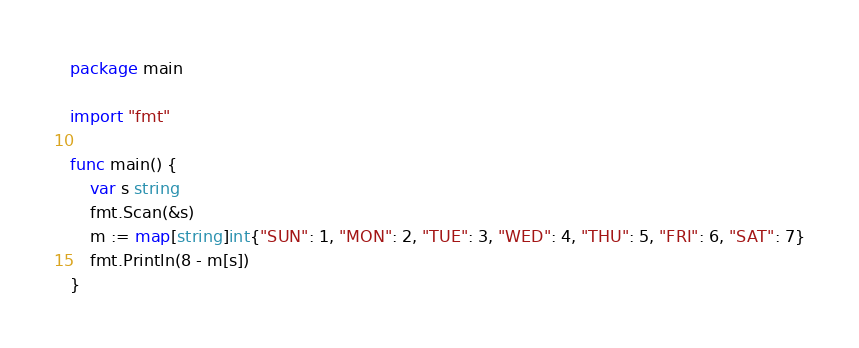<code> <loc_0><loc_0><loc_500><loc_500><_Go_>package main

import "fmt"

func main() {
	var s string
	fmt.Scan(&s)
	m := map[string]int{"SUN": 1, "MON": 2, "TUE": 3, "WED": 4, "THU": 5, "FRI": 6, "SAT": 7}
	fmt.Println(8 - m[s])
}
</code> 